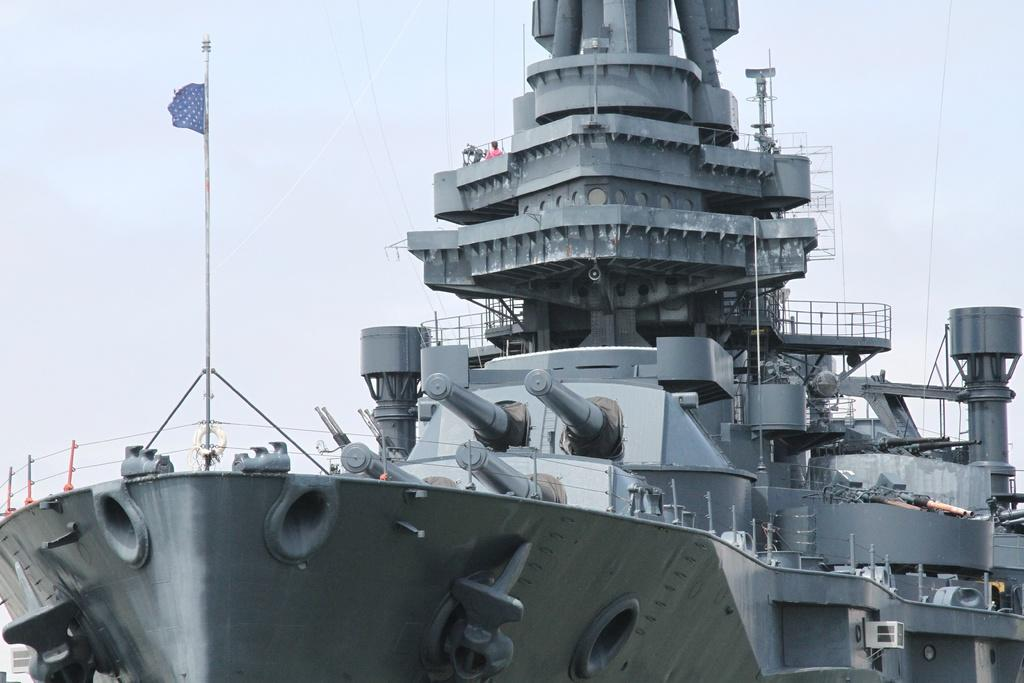What is the main subject in the foreground of the image? There is a ship in the foreground of the image. What other objects can be seen in the foreground of the image? There are metal objects and a flag pole in the foreground of the image. What can be seen in the background of the image? The sky is visible in the background of the image. Can we determine the time of day when the image was taken? The image might have been taken during the day, based on the visibility of the sky and the presence of sunlight. What type of substance is being transported in the sack on the ship? There is no sack visible on the ship in the image, so it is not possible to determine what type of substance might be transported. 